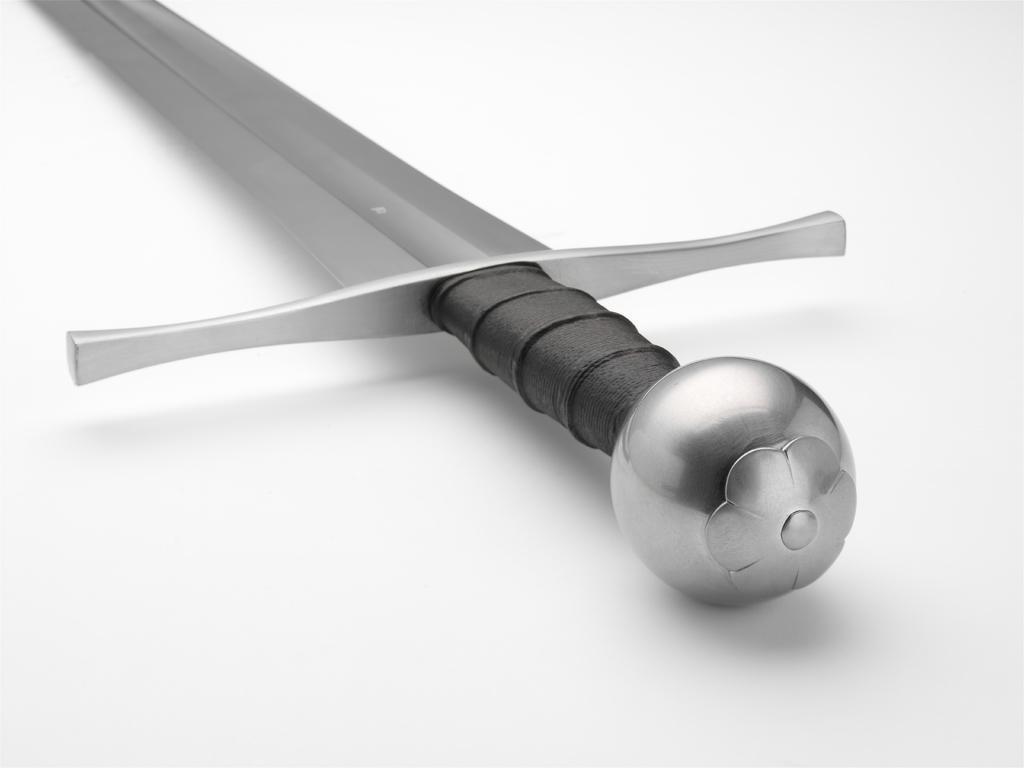Please provide a concise description of this image. In this image I can see the white colored surface and on the surface I can see a knife which is ash, silver and black in color. 